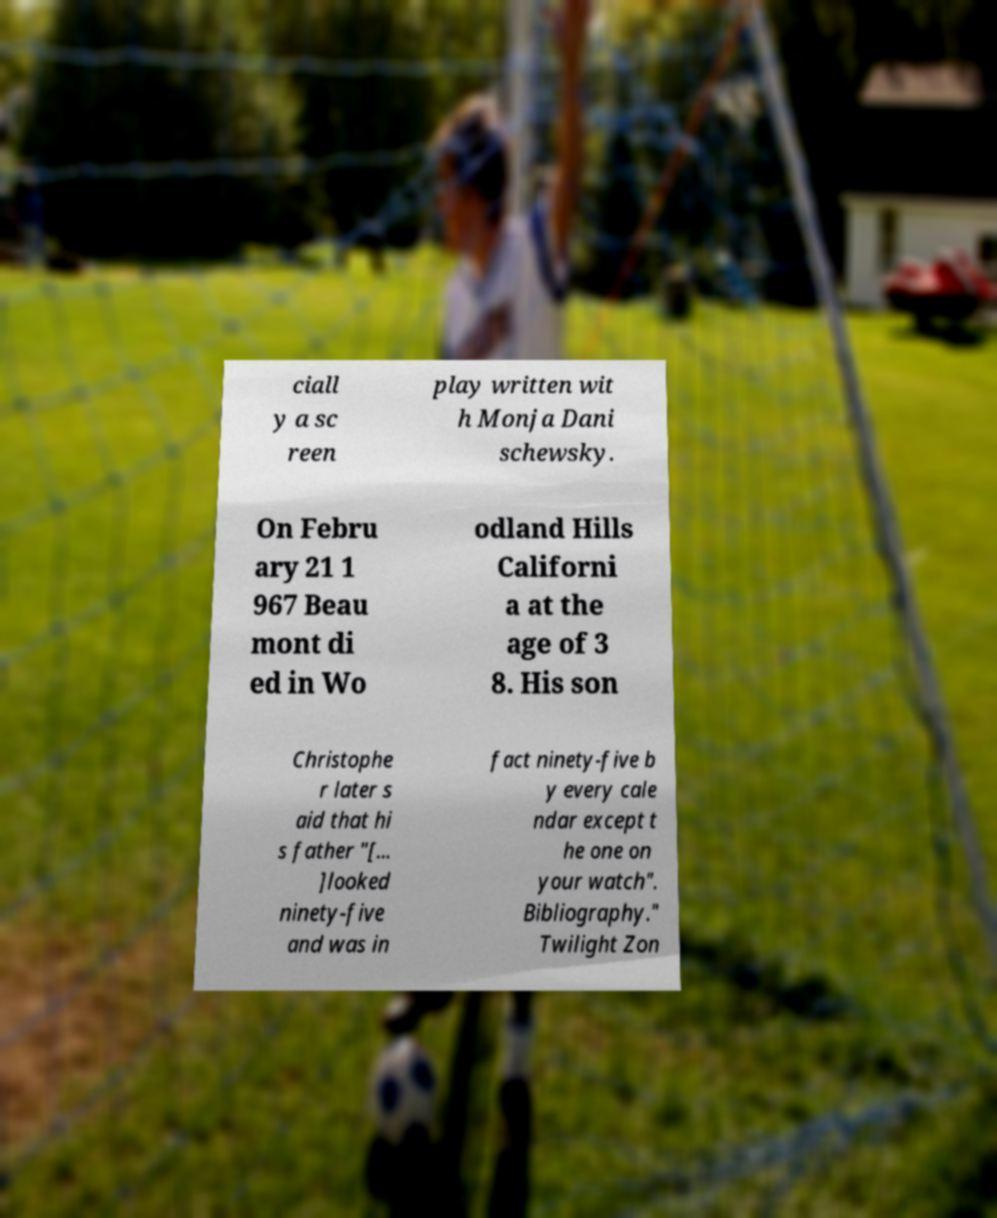I need the written content from this picture converted into text. Can you do that? ciall y a sc reen play written wit h Monja Dani schewsky. On Febru ary 21 1 967 Beau mont di ed in Wo odland Hills Californi a at the age of 3 8. His son Christophe r later s aid that hi s father "[... ]looked ninety-five and was in fact ninety-five b y every cale ndar except t he one on your watch". Bibliography." Twilight Zon 